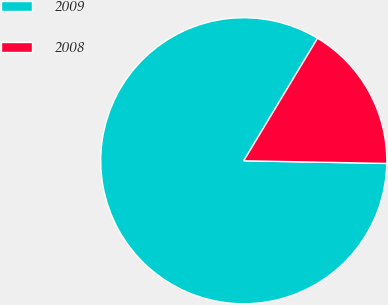Convert chart. <chart><loc_0><loc_0><loc_500><loc_500><pie_chart><fcel>2009<fcel>2008<nl><fcel>83.33%<fcel>16.67%<nl></chart> 